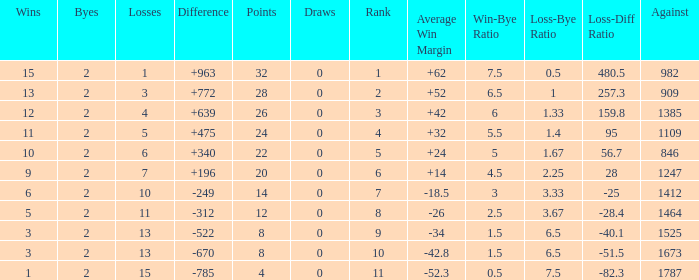What is the highest number listed under against when there were 15 losses and more than 1 win? None. Can you give me this table as a dict? {'header': ['Wins', 'Byes', 'Losses', 'Difference', 'Points', 'Draws', 'Rank', 'Average Win Margin', 'Win-Bye Ratio', 'Loss-Bye Ratio', 'Loss-Diff Ratio', 'Against'], 'rows': [['15', '2', '1', '+963', '32', '0', '1', '+62', '7.5', '0.5', '480.5', '982'], ['13', '2', '3', '+772', '28', '0', '2', '+52', '6.5', '1', '257.3', '909'], ['12', '2', '4', '+639', '26', '0', '3', '+42', '6', '1.33', '159.8', '1385'], ['11', '2', '5', '+475', '24', '0', '4', '+32', '5.5', '1.4', '95', '1109'], ['10', '2', '6', '+340', '22', '0', '5', '+24', '5', '1.67', '56.7', '846'], ['9', '2', '7', '+196', '20', '0', '6', '+14', '4.5', '2.25', '28', '1247'], ['6', '2', '10', '-249', '14', '0', '7', '-18.5', '3', '3.33', '-25', '1412'], ['5', '2', '11', '-312', '12', '0', '8', '-26', '2.5', '3.67', '-28.4', '1464'], ['3', '2', '13', '-522', '8', '0', '9', '-34', '1.5', '6.5', '-40.1', '1525'], ['3', '2', '13', '-670', '8', '0', '10', '-42.8', '1.5', '6.5', '-51.5', '1673'], ['1', '2', '15', '-785', '4', '0', '11', '-52.3', '0.5', '7.5', '-82.3', '1787']]} 